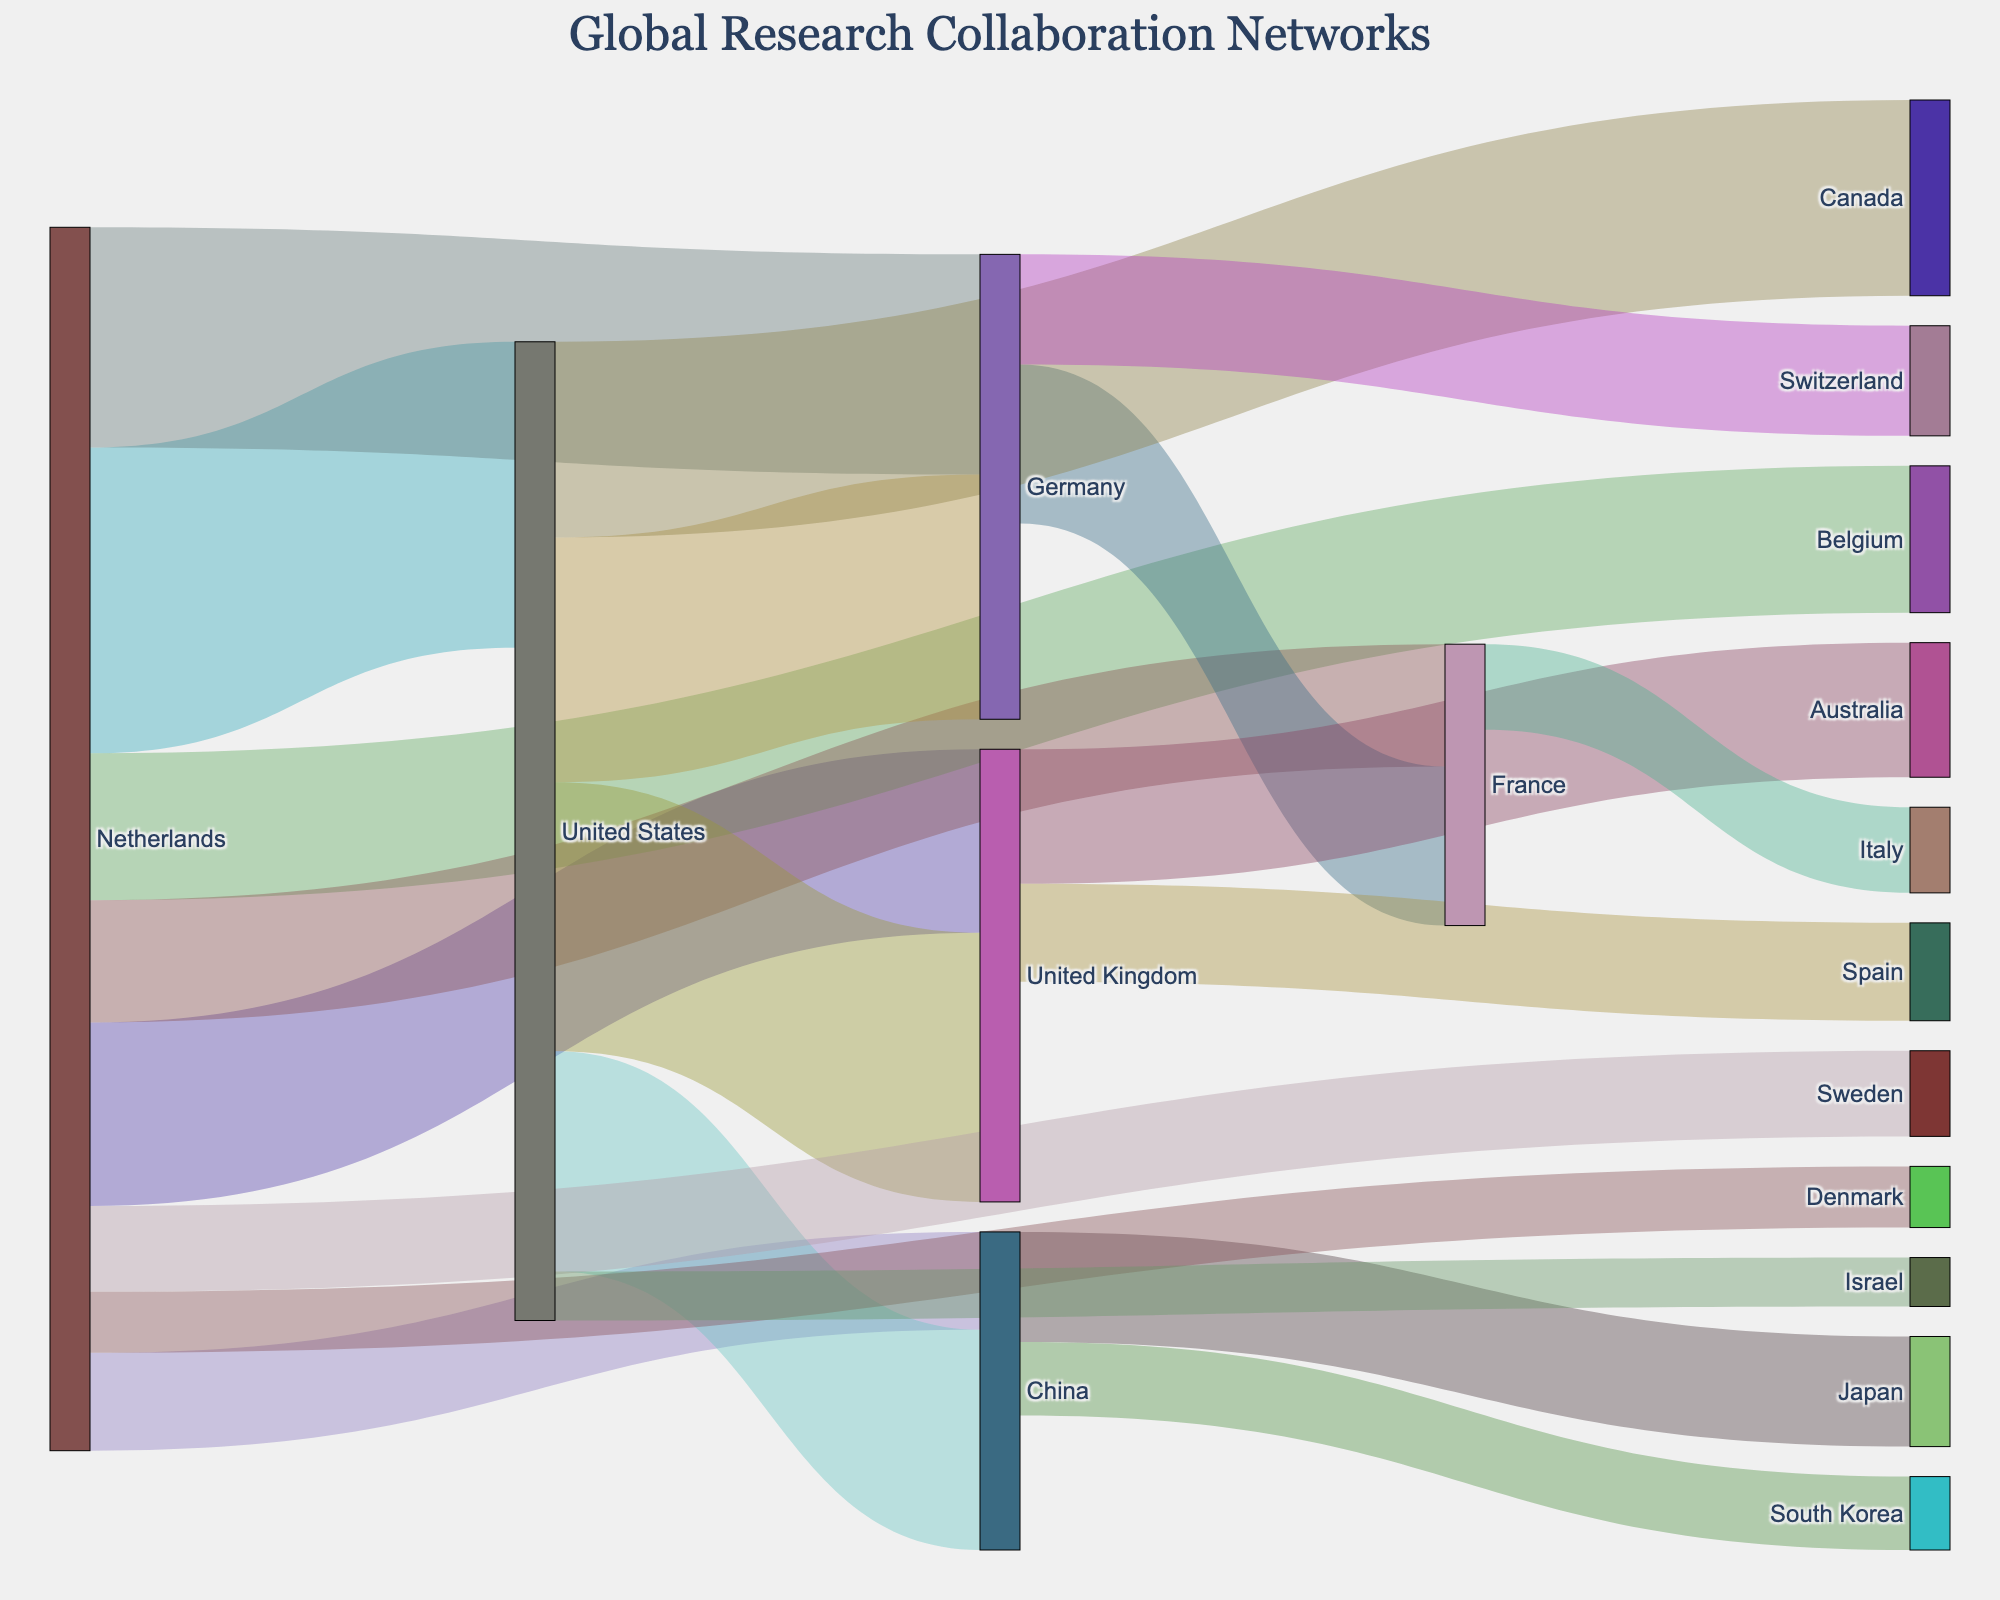What's the title of the figure? The title is usually displayed prominently at the top of the figure. Here, it reads "Global Research Collaboration Networks"
Answer: Global Research Collaboration Networks How many countries are involved in collaborations with the Netherlands? The nodes connected directly by links originating from the Netherlands indicate the countries involved in collaborations. There are nine such connections: United States, Germany, United Kingdom, Belgium, France, China, Sweden, Denmark, and Switzerland.
Answer: 9 Which collaboration has the highest value in the entire figure, and what is that value? By examining the thickness and labeled values on the links, the collaboration between the Netherlands and the United States has the largest value, which is 2500.
Answer: Netherlands–United States, 2500 What's the total collaboration value between the United States and other countries? Add up the values of all the links connected to the United States node: Netherlands (2500), United Kingdom (2200), Germany (2000), China (1800), Canada (1600), and Israel (400). The sum is 2500 + 2200 + 2000 + 1800 + 1600 + 400 = 10500.
Answer: 10500 Between the Netherlands and China, which country has more collaboration links, and how many? Count the number of links connected to both nodes. The Netherlands has links to nine countries, whereas China has links to three countries. Thus, the Netherlands has more collaboration links.
Answer: Netherlands with 9 links What's the difference in collaboration value between Germany and the United States and Germany and Switzerland? Find the values of the links: Germany-United States is 2000 and Germany-Switzerland is 900. Subtract the latter from the former: 2000 - 900 = 1100.
Answer: 1100 Which country has the least collaboration value with the Netherlands, and what is the value? By examining the values of the links originating from the Netherlands, Denmark has the lowest value which is 500.
Answer: Denmark, 500 Are Germany’s collaborations with France higher or lower than its collaborations with Switzerland? Compare the values: Germany-France is 1300 and Germany-Switzerland is 900. Germany's collaboration with France is higher.
Answer: Higher What's the average value of the Netherlands' collaborations? Sum the values of all the Netherlands' links: 2500 + 1800 + 1500 + 1200 + 1000 + 800 + 700 + 500 = 10000. There are 8 collaborations, so the average value is 10000 / 8 = 1250.
Answer: 1250 Which two countries have the highest number of direct collaboration links among themselves, excluding the Netherlands? Count the direct links for each country. The United States has collaborations with 6 countries. Germany and the United Kingdom both have 3 each, but the United States has the most.
Answer: United States, 6 